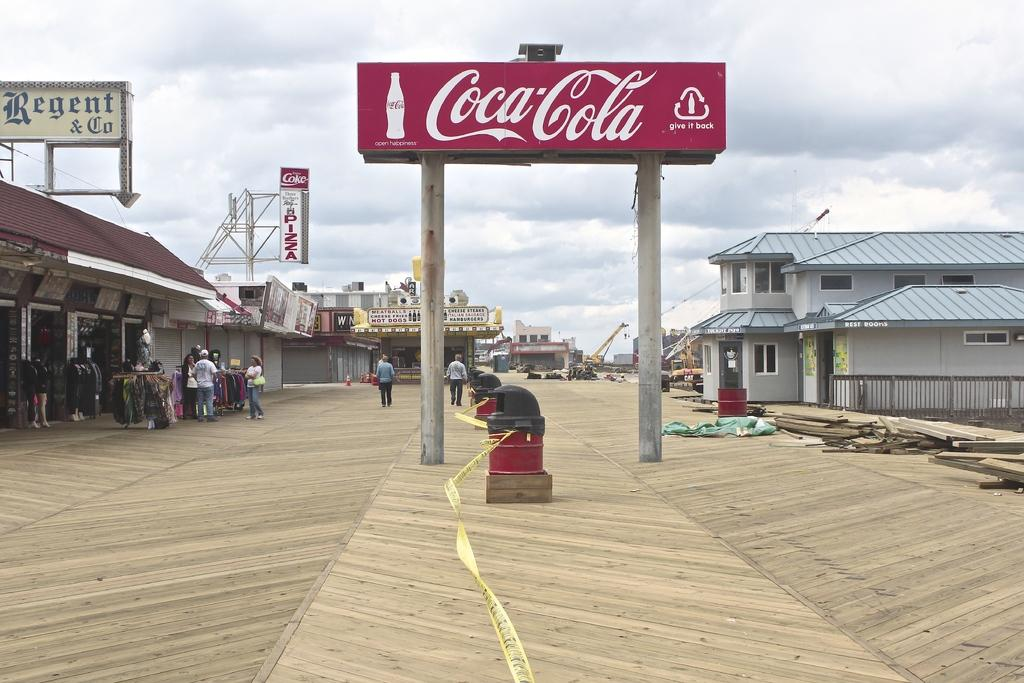What type of structures are present in the image? There are buildings with windows in the image. Are there any people visible in the image? Yes, there are people standing in the image. What can be seen in the background of the image? The sky is visible in the image. What type of plate is being used for the activity in the image? There is no plate or activity present in the image; it features buildings and people. How does the health of the people in the image compare to the health of the buildings? The health of the people and the buildings cannot be compared, as the image does not provide any information about their health. 